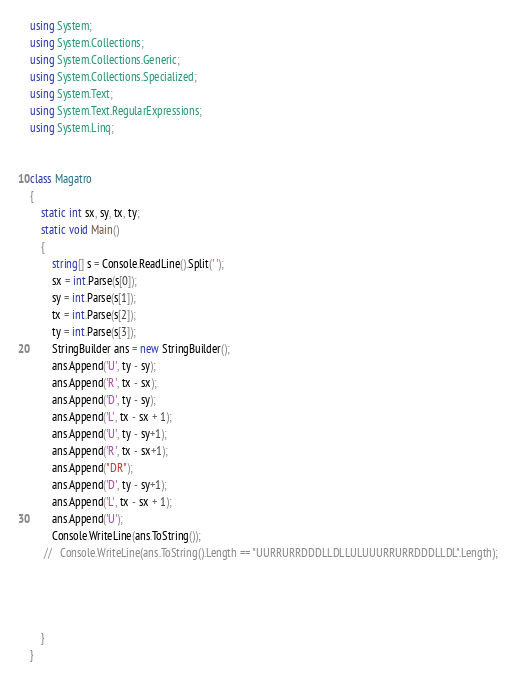<code> <loc_0><loc_0><loc_500><loc_500><_C#_>using System;
using System.Collections;
using System.Collections.Generic;
using System.Collections.Specialized;
using System.Text;
using System.Text.RegularExpressions;
using System.Linq;


class Magatro
{
    static int sx, sy, tx, ty;
    static void Main()
    {
        string[] s = Console.ReadLine().Split(' ');
        sx = int.Parse(s[0]);
        sy = int.Parse(s[1]);
        tx = int.Parse(s[2]);
        ty = int.Parse(s[3]);
        StringBuilder ans = new StringBuilder();
        ans.Append('U', ty - sy);
        ans.Append('R', tx - sx);
        ans.Append('D', ty - sy);
        ans.Append('L', tx - sx + 1);
        ans.Append('U', ty - sy+1);
        ans.Append('R', tx - sx+1);
        ans.Append("DR");
        ans.Append('D', ty - sy+1);
        ans.Append('L', tx - sx + 1);
        ans.Append('U');
        Console.WriteLine(ans.ToString());
     //   Console.WriteLine(ans.ToString().Length == "UURRURRDDDLLDLLULUUURRURRDDDLLDL".Length);
        



    }
}
</code> 